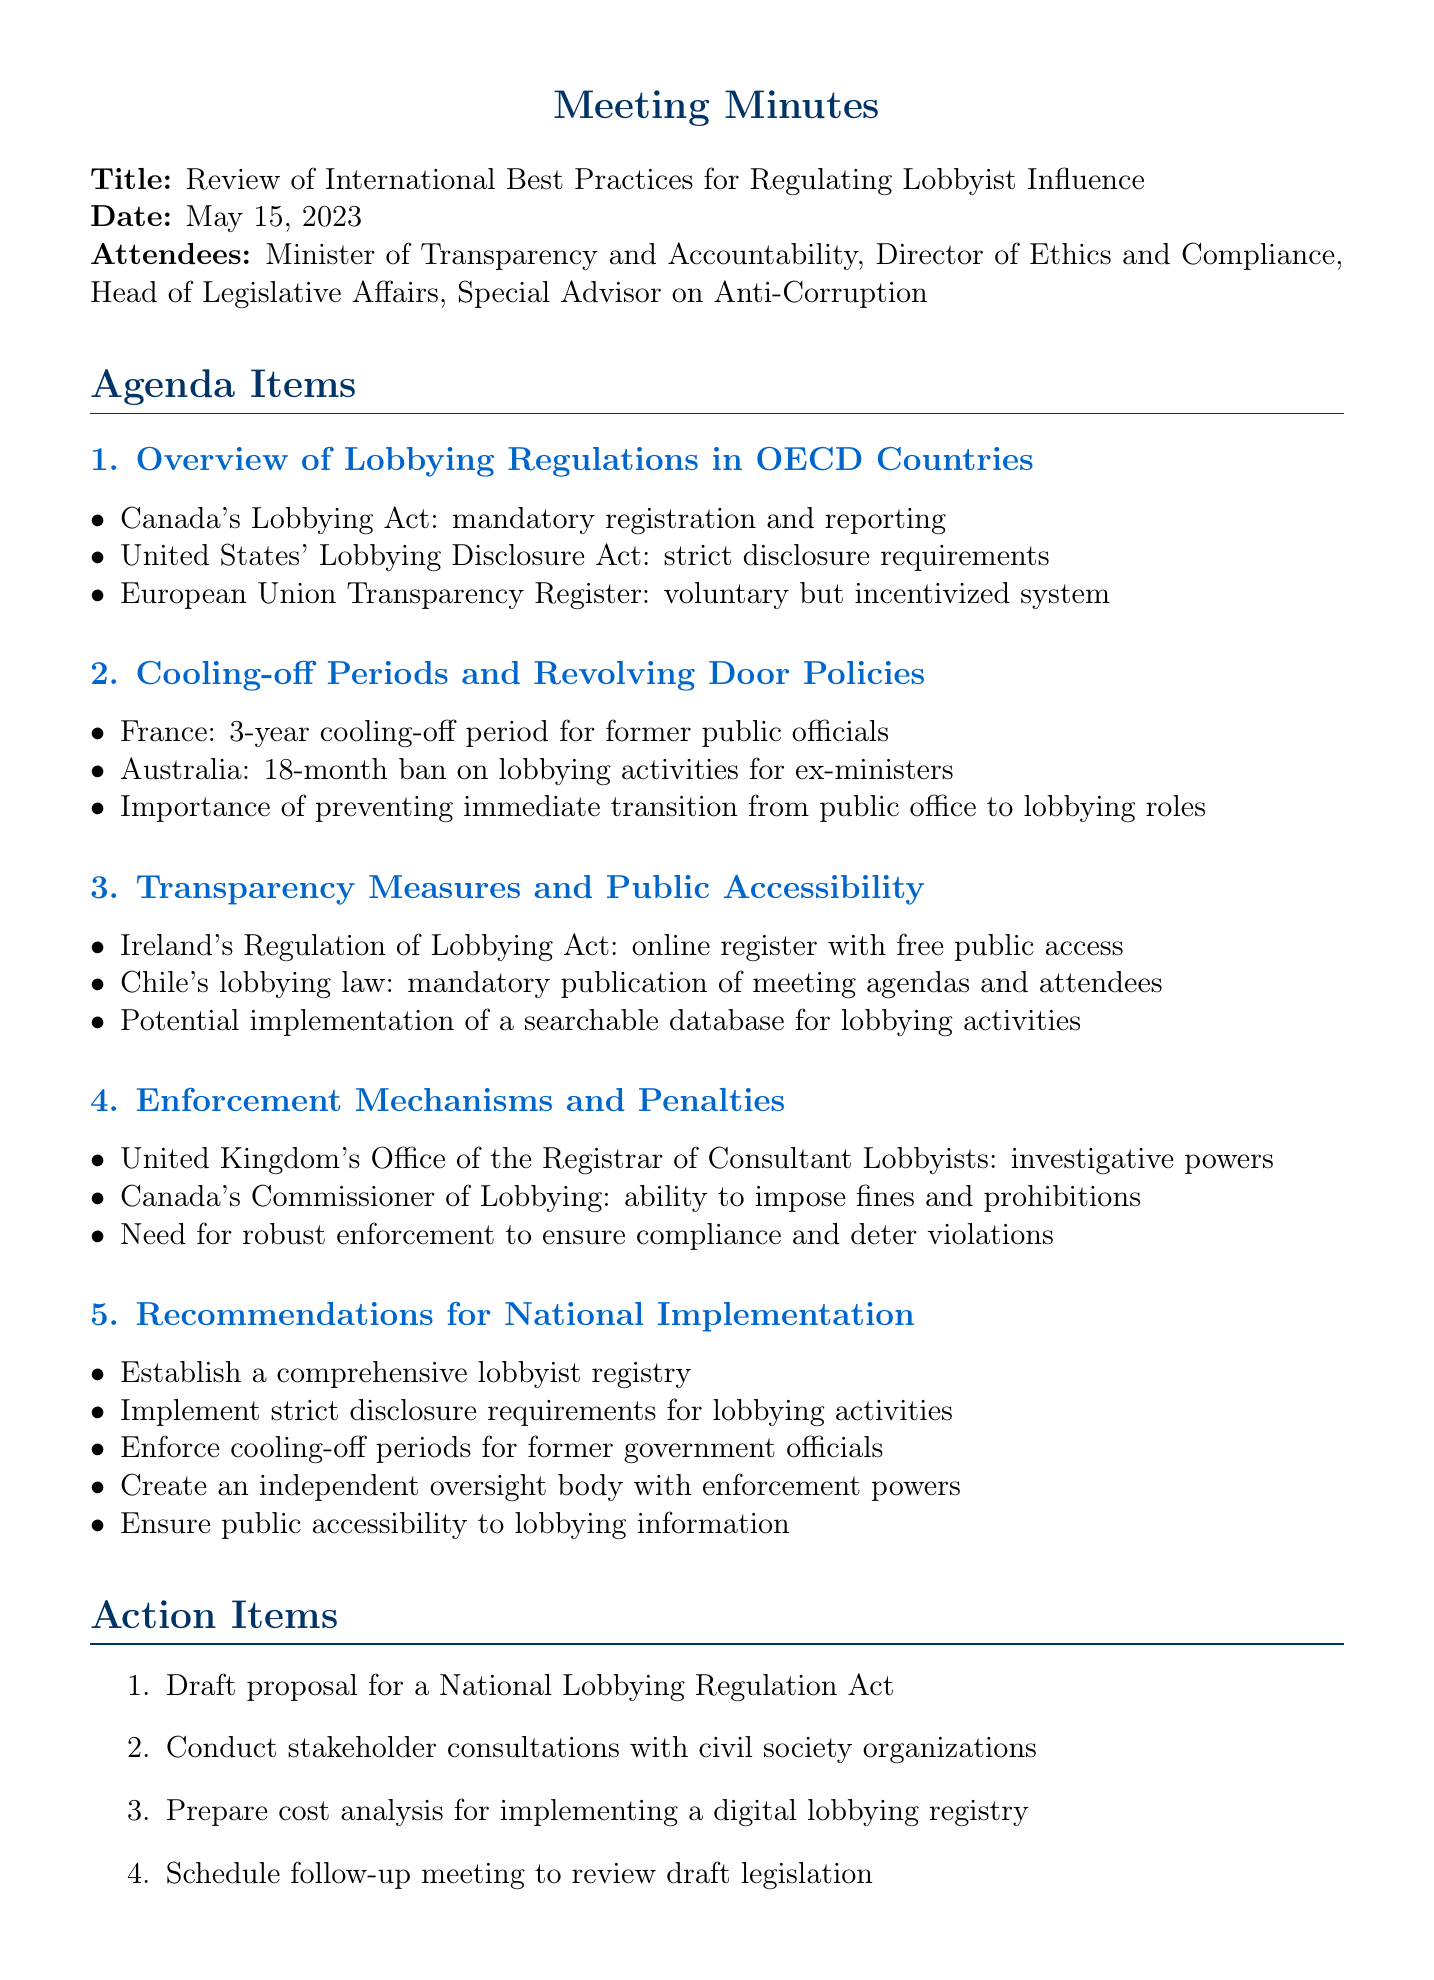What was the date of the meeting? The date of the meeting is specified in the document.
Answer: May 15, 2023 Who attended the meeting? The attendees are listed in the document under the attendees section.
Answer: Minister of Transparency and Accountability, Director of Ethics and Compliance, Head of Legislative Affairs, Special Advisor on Anti-Corruption What is one key point from the cooling-off periods discussion? Key points are listed under each agenda item, including those related to cooling-off periods.
Answer: France: 3-year cooling-off period for former public officials Which country has a voluntary transparency register? The overview of lobbying regulations includes specific countries and their systems.
Answer: European Union What is a recommendation for national implementation mentioned in the document? Recommendations are provided under the last agenda item in the document.
Answer: Establish a comprehensive lobbyist registry How long is the ban on lobbying activities for ex-ministers in Australia? The document provides specific duration related to revolving door policies for different countries.
Answer: 18-month ban What is one action item listed in the meeting minutes? Action items are clearly listed towards the end of the document.
Answer: Draft proposal for a National Lobbying Regulation Act What are the penalties associated with the United Kingdom's lobbying regulations? The document mentions enforcement mechanisms and the ability to impose fines as a penalty in the UK.
Answer: Investigative powers 